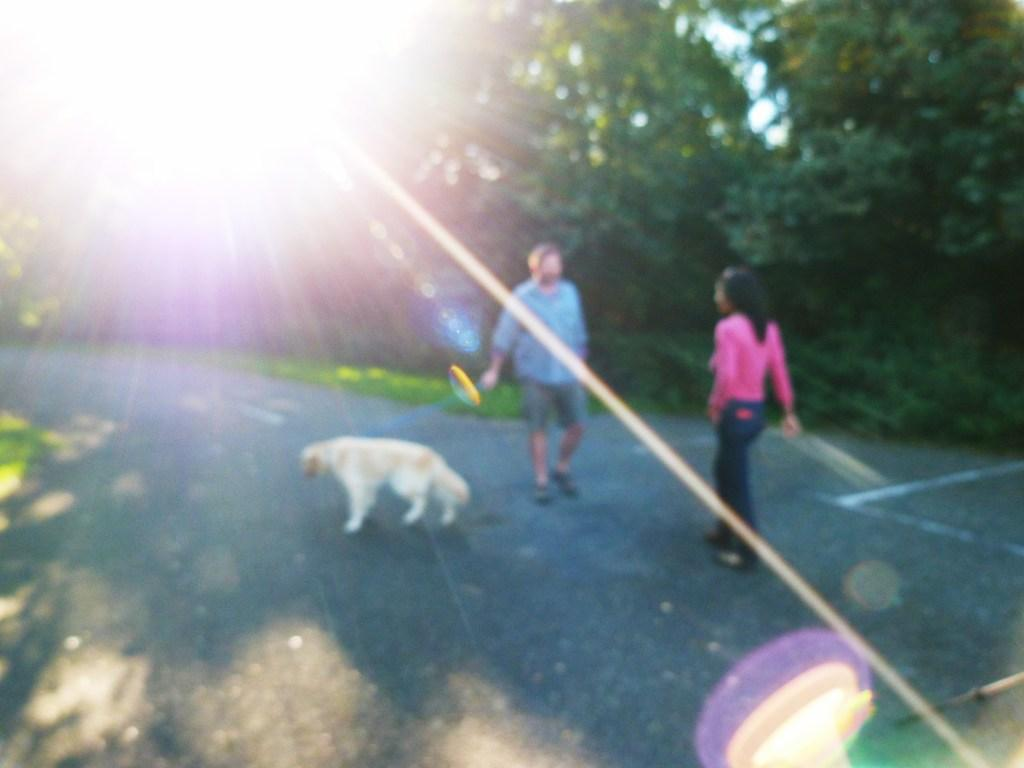How many people are present in the image? There are two persons in the image. What is the dog doing in the image? The dog is on the road in the image. What type of vegetation can be seen in the image? There are trees in the image. What is the source of light in the image? The sunlight is visible in the image. Can you see the boundary between the seashore and the land in the image? There is no seashore present in the image, so it is not possible to see the boundary between the seashore and the land. 